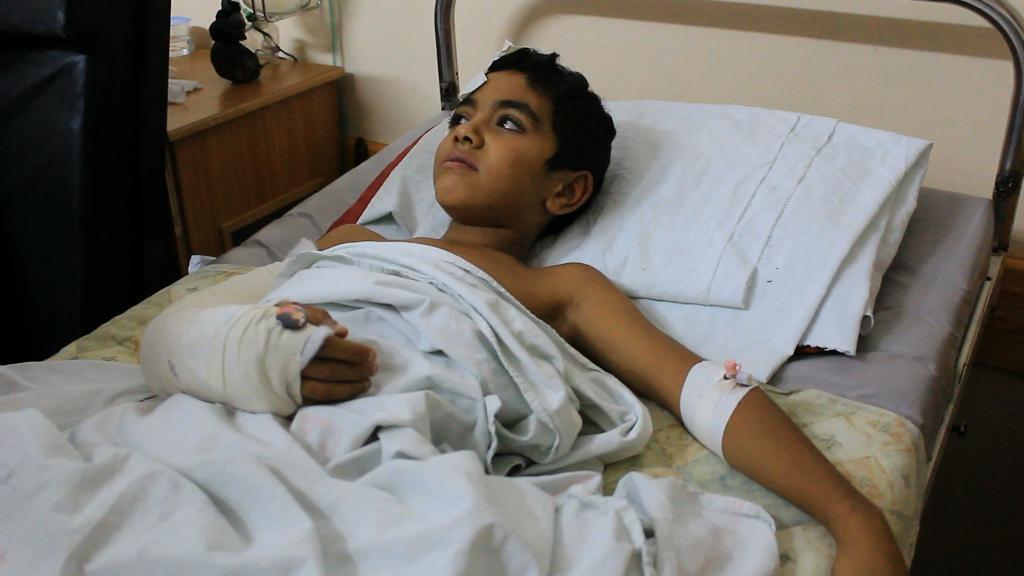Describe this image in one or two sentences. In this image in the center there is one boy who is sleeping on bed and it seems that he is injured, beside the bed there is one table. On the table there are some objects. 